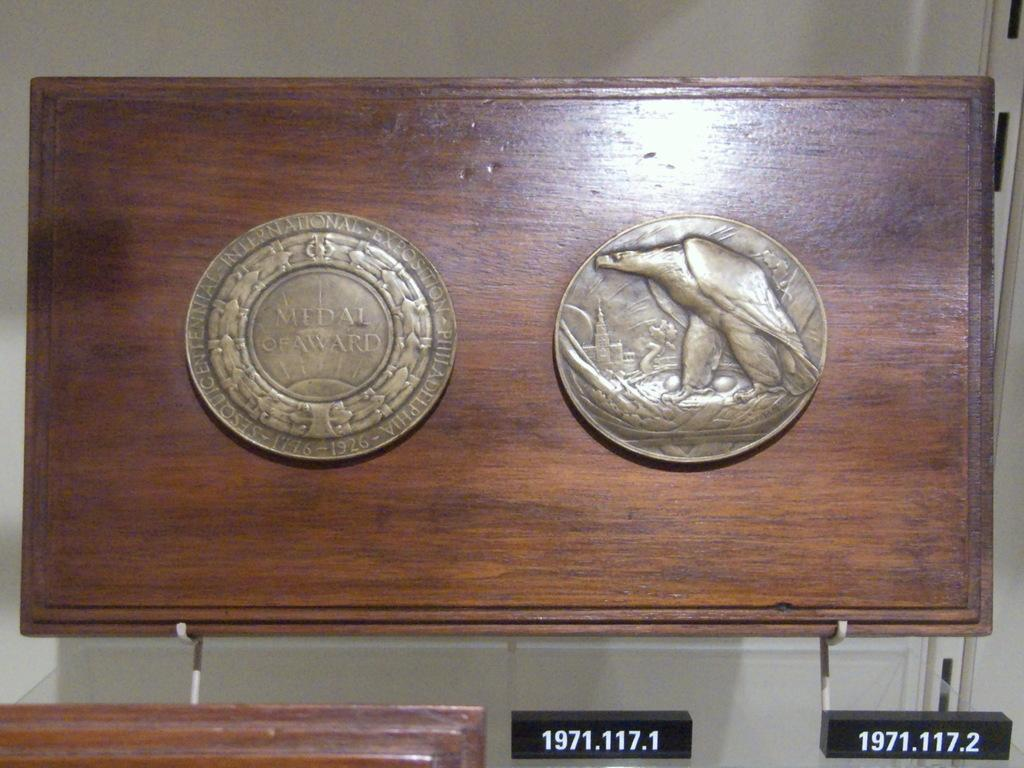<image>
Render a clear and concise summary of the photo. Two coins next to one another with one saying Medal of Award. 